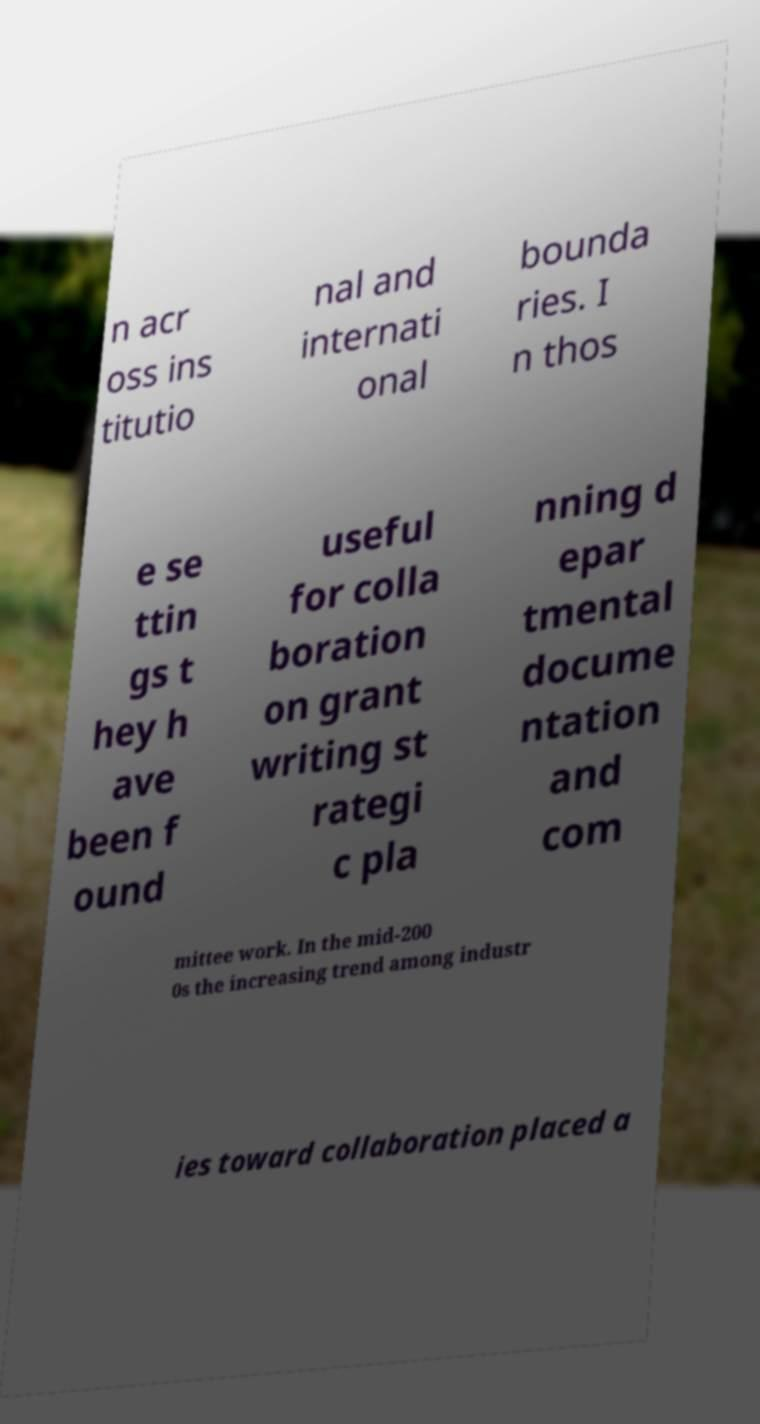Please read and relay the text visible in this image. What does it say? n acr oss ins titutio nal and internati onal bounda ries. I n thos e se ttin gs t hey h ave been f ound useful for colla boration on grant writing st rategi c pla nning d epar tmental docume ntation and com mittee work. In the mid-200 0s the increasing trend among industr ies toward collaboration placed a 